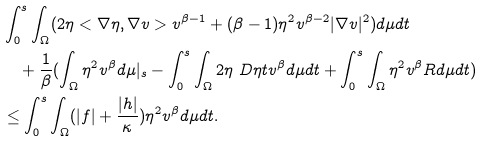<formula> <loc_0><loc_0><loc_500><loc_500>& \int _ { 0 } ^ { s } \int _ { \Omega } ( 2 \eta < \nabla \eta , \nabla v > v ^ { \beta - 1 } + ( \beta - 1 ) \eta ^ { 2 } v ^ { \beta - 2 } | \nabla v | ^ { 2 } ) d \mu d t \\ & \quad + \frac { 1 } { \beta } ( \int _ { \Omega } \eta ^ { 2 } v ^ { \beta } d \mu | _ { s } - \int _ { 0 } ^ { s } \int _ { \Omega } 2 \eta \ D { \eta } { t } v ^ { \beta } d \mu d t + \int _ { 0 } ^ { s } \int _ { \Omega } \eta ^ { 2 } v ^ { \beta } R d \mu d t ) \\ & \leq \int _ { 0 } ^ { s } \int _ { \Omega } ( | f | + \frac { | h | } { \kappa } ) \eta ^ { 2 } v ^ { \beta } d \mu d t .</formula> 